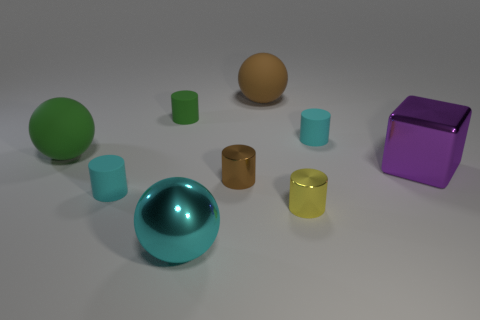Does the cyan thing to the left of the tiny green matte thing have the same shape as the big matte object that is on the left side of the large cyan metallic sphere?
Your response must be concise. No. Are there fewer big cyan metal balls on the right side of the large brown thing than big metal blocks left of the cyan shiny thing?
Ensure brevity in your answer.  No. What number of other things are there of the same shape as the large cyan object?
Your answer should be very brief. 2. What shape is the other large object that is the same material as the big cyan thing?
Provide a succinct answer. Cube. There is a tiny matte thing that is both behind the big block and on the left side of the yellow metallic object; what is its color?
Your answer should be compact. Green. Do the large object right of the small yellow metal cylinder and the big cyan thing have the same material?
Provide a short and direct response. Yes. Is the number of green rubber cylinders to the right of the large cyan metal ball less than the number of large purple metal blocks?
Your answer should be very brief. Yes. Are there any green things made of the same material as the big purple cube?
Give a very brief answer. No. Do the green matte ball and the matte thing that is in front of the small brown object have the same size?
Keep it short and to the point. No. Are there any big blocks that have the same color as the big metal sphere?
Make the answer very short. No. 